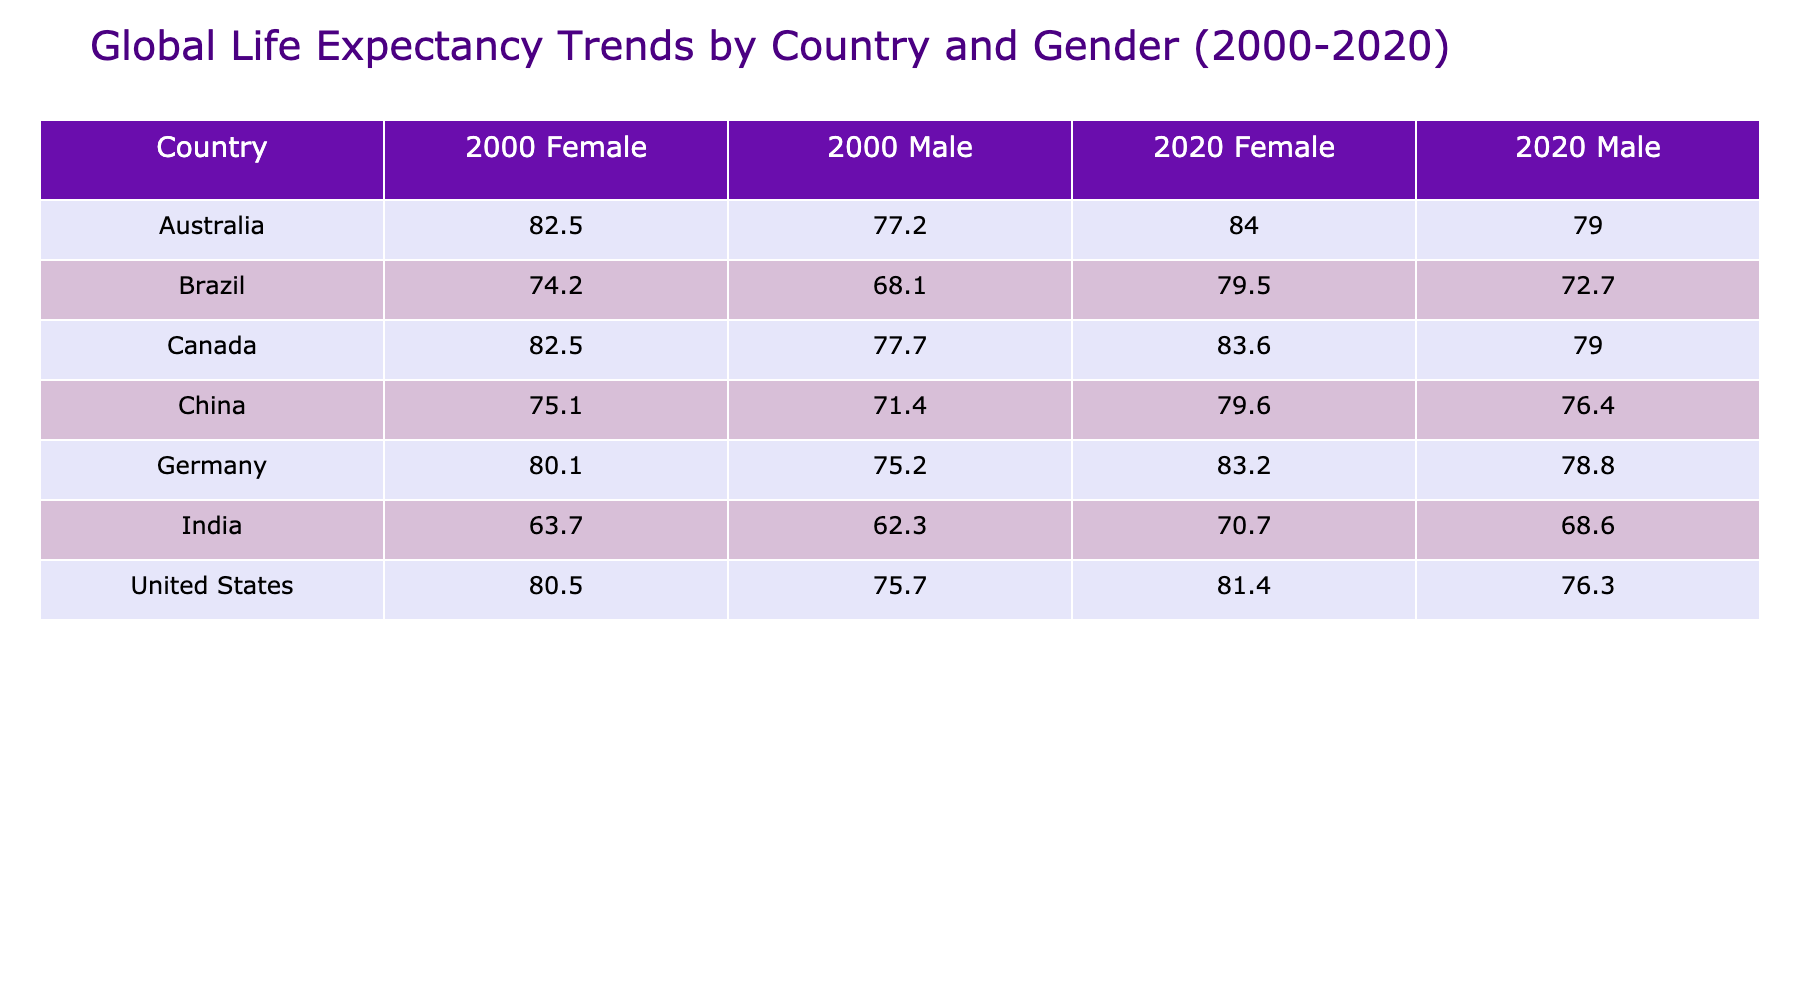What was the life expectancy for males in Canada in 2020? The table shows that for Canada in 2020, the life expectancy for males is 79.0 years.
Answer: 79.0 Which country had the lowest life expectancy for females in 2000? Looking at the data for females in 2000, India had the lowest life expectancy at 63.7 years.
Answer: India What is the difference in life expectancy for males in India from 2000 to 2020? In 2000, the life expectancy for males in India was 62.3 years, and in 2020 it increased to 68.6 years. The difference is 68.6 - 62.3 = 6.3 years.
Answer: 6.3 Did life expectancy for females in Australia increase from 2000 to 2020? In 2000, the life expectancy for females in Australia was 82.5 years, and in 2020 it increased to 84.0 years, indicating that it did indeed increase.
Answer: Yes What is the average life expectancy for males across all countries in 2020? Summing the male life expectancies for 2020 (76.3 + 79.0 + 78.8 + 68.6 + 72.7 + 76.4 + 79.0) gives 460.0. Dividing by the number of countries (7) results in an average of 460.0 / 7 = 65.7.
Answer: 65.7 Which gender had a higher life expectancy in Germany in 2020? In Germany in 2020, males had a life expectancy of 78.8 years and females had 83.2 years. Therefore, females had a higher life expectancy.
Answer: Females Was the life expectancy for male citizens of the United States higher in 2020 compared to 2000? In 2000, males had a life expectancy of 75.7 years, which increased to 76.3 years in 2020. So yes, it was higher in 2020.
Answer: Yes Which country showed the largest increase in female life expectancy from 2000 to 2020? For countries listed, Brazil had a female life expectancy that increased from 74.2 years in 2000 to 79.5 years in 2020, which is the largest increase of 5.3 years.
Answer: Brazil 